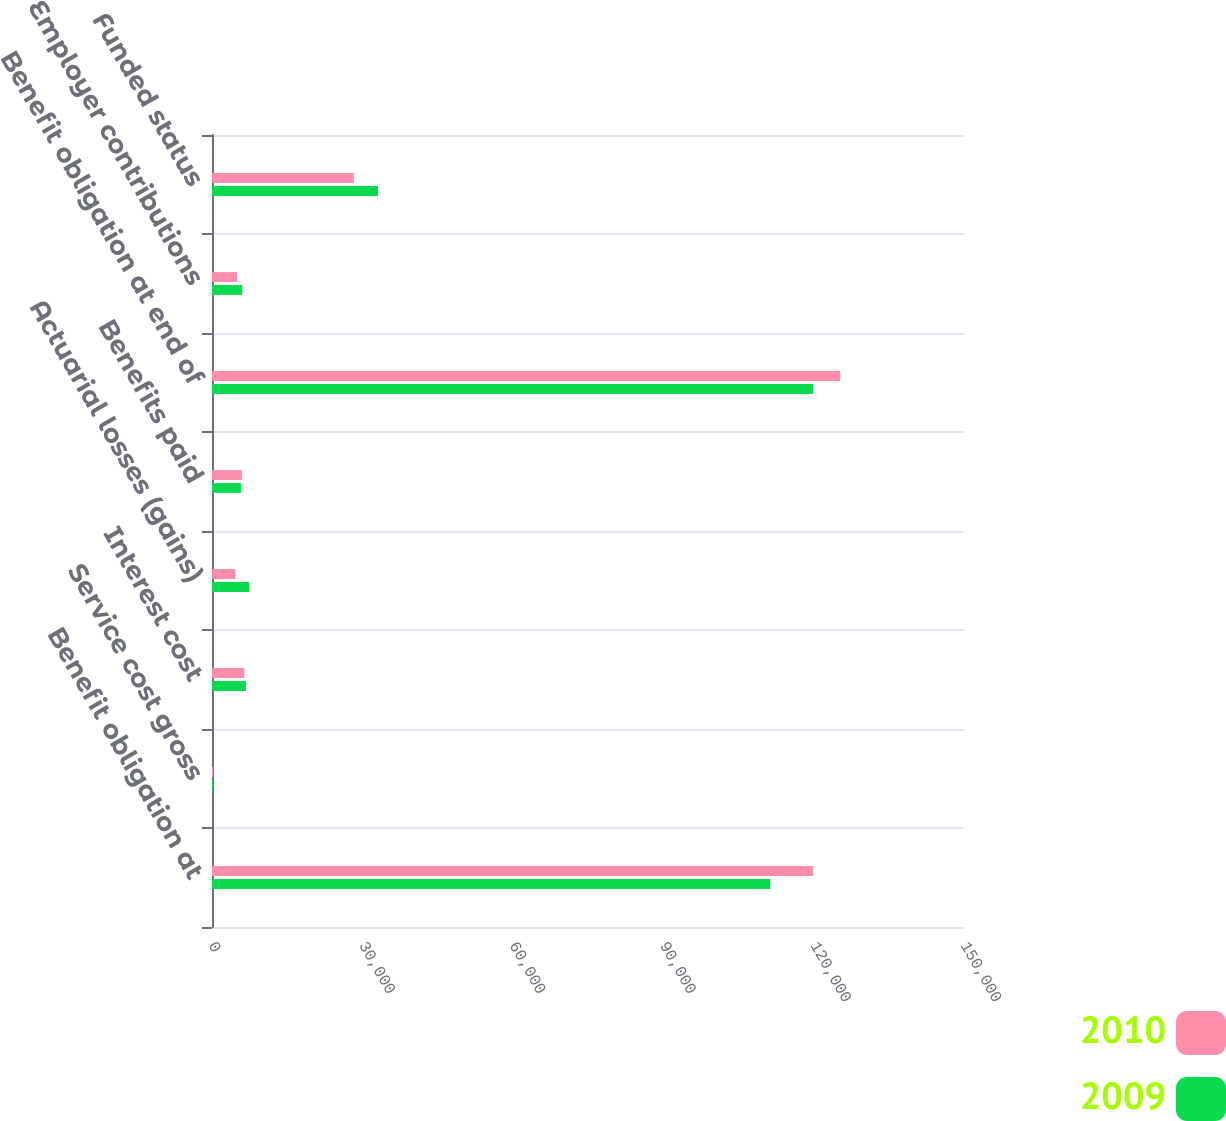Convert chart to OTSL. <chart><loc_0><loc_0><loc_500><loc_500><stacked_bar_chart><ecel><fcel>Benefit obligation at<fcel>Service cost gross<fcel>Interest cost<fcel>Actuarial losses (gains)<fcel>Benefits paid<fcel>Benefit obligation at end of<fcel>Employer contributions<fcel>Funded status<nl><fcel>2010<fcel>119930<fcel>264<fcel>6439<fcel>4661<fcel>5954<fcel>125340<fcel>5058<fcel>28300<nl><fcel>2009<fcel>111368<fcel>183<fcel>6782<fcel>7431<fcel>5834<fcel>119930<fcel>6045<fcel>33129<nl></chart> 